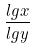Convert formula to latex. <formula><loc_0><loc_0><loc_500><loc_500>\frac { l g x } { l g y }</formula> 